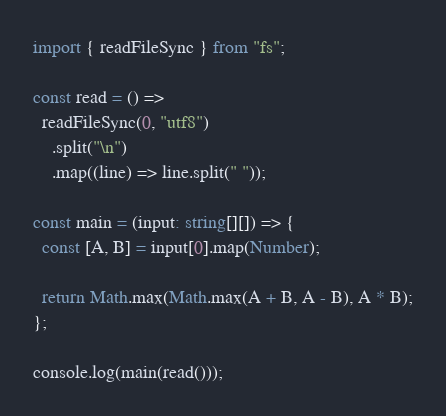Convert code to text. <code><loc_0><loc_0><loc_500><loc_500><_TypeScript_>import { readFileSync } from "fs";

const read = () =>
  readFileSync(0, "utf8")
    .split("\n")
    .map((line) => line.split(" "));

const main = (input: string[][]) => {
  const [A, B] = input[0].map(Number);

  return Math.max(Math.max(A + B, A - B), A * B);
};

console.log(main(read()));
</code> 